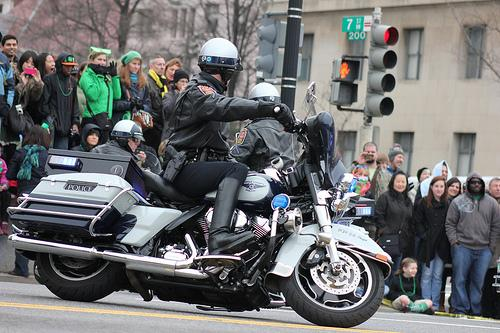Describe the elements in the scene related to street and vehicle safety. There are traffic signs, pedestrian light with a bright red hand, street light on red, traffic lights on the pole, a part of a guard, helmets on police officers, and a part of a yellow line on the road. Identify the features of the road and motorcycles that can be seen in the image. A part of a road with a yellow line can be seen. Two motorcycles are in the image, one silver and black, and another black and grey. How are the people in the image dressed for the weather? People are wearing warm clothes like grey hoodies, green jackets, and yellow scarves. List the objects related to the police in the image and what they are doing. There are police on a motorcycle, wearing helmets and black boots. One of the policemen's helmet is white. They are riding a silver and black motorcycle. Describe the traffic signs and lights in the image. There is a traffic sign, a pedestrian light with a bright red hand, and a street light set on red. There is also a traffic light on a pole. What are some objects in the image that are not people, vehicles, or signs? There are two windows, trees without foliage, and wheels of the motorcycles. Mention the details of the crowd and what some individuals are doing. There is a crowd of people on the sidewalk. A man is taking a photo, a girl in a green jacket has a pink phone, and a boy is sitting on the ground. Count and describe the helmets in the image. There are four helmets: Two on police officers, one black and white helmet, and part of another helmet. Describe the attire of the people in the image, including accessories. A man has a grey hoodie, a girl wears a green jacket, another man has a yellow scarf, and a lady holds a pink cellphone. One person has a green and orange cap. Explain the colors of the objects in the image that stand out. The bright red hand on the pedestrian light, the blue round light, and the green sign with numbers grab attention. Is the girl wearing the green jacket carrying an orange phone? There is a girl wearing a green jacket and another person holding a pink phone, but there is no mention of a girl specifically carrying an orange phone. Do the people watching the bike riders have colorful umbrellas? No, it's not mentioned in the image. Tell me what distinguishes the motorcycle at position X:45 Y:142. It is a silver and black motorcycle (Width:332 Height:332). Name a few objects that appear to be interacting with each other. Police on a motorcycle, a crowd of people watching bike riders, and traffic signs and lights Which object has a blue round light? A motorcycle (Coordinates: X:267 Y:192 Width:25 Height:25) Do the people look happy or unhappy? Cannot determine without the actual image. Describe the scene happening beside the street light set on red. Police on motorcycles, crowds of people, various traffic signs, and pedestrians (X:367 Y:15 Width:42 Height:42) Describe the type of helmet the police are wearing. The police helmet is white (X:201 Y:38 Width:53 Height:53). How many motorcyclists are present in the image? Two motorcyclists (X:51 Y:30 Width:369 Height:369) What is the position of the pedestrian light? X:329 Y:51 Width:38 Height:38 Is there a traffic sign floating in mid-air? There is a traffic sign in the image, but it is not described as floating in mid-air. It is bound by its X and Y positions. What color sweater is the man wearing a grey hoodie on? Grey (X:453 Y:207 Width:29 Height:29) Describe the interesting aspects of the image. There are police on motorcycles, a crowd of people on the sidewalk, and various traffic signs and lights. What can you notice about the trees in the image? The trees don't have foliage (X:41 Y:0 Width:220 Height:220). Translate the text on the green sign with numbers. There is no text to translate, only numbers and positions are provided. Can you find any object that is part of a yellow line? Yes, there is a part of a yellow line (X:182 Y:304 Width:31 Height:31). Please explain the attire of the people in this image. People are dressed in warm clothes, wearing jackets, hoodies, and scarfs (X:378 Y:160 Width:119 Height:119). What color is the light in the traffic sign at position X:376 Y:22? Red Find the man wearing a green and orange cap and provide the coordinates. X:58 Y:47 Width:21 Height:21 